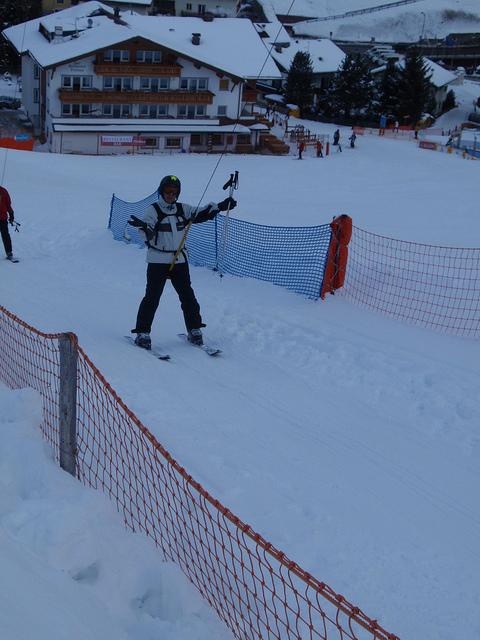What color is the fence?
Concise answer only. Red. Is the fence metal?
Answer briefly. No. Has it snowed heavily here?
Concise answer only. Yes. 